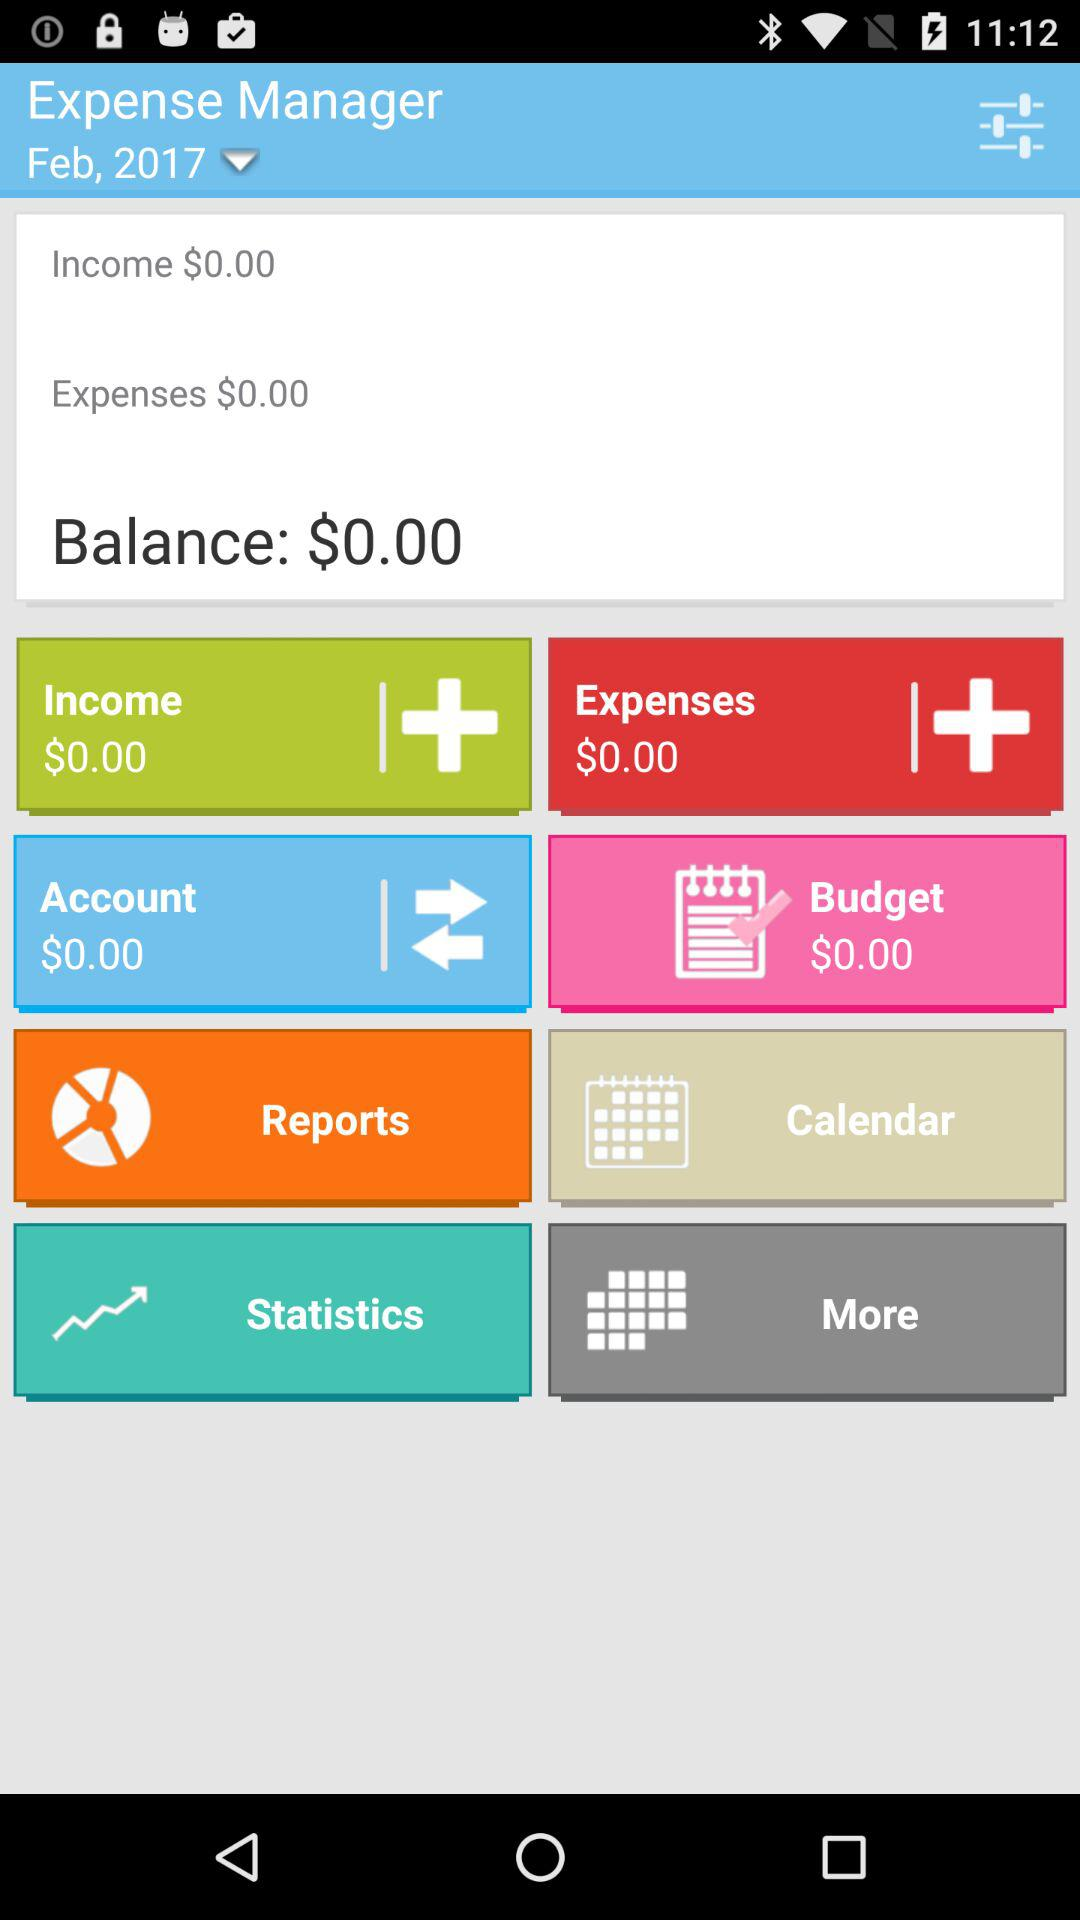What is the total amount of money in the account?
Answer the question using a single word or phrase. $0.00 